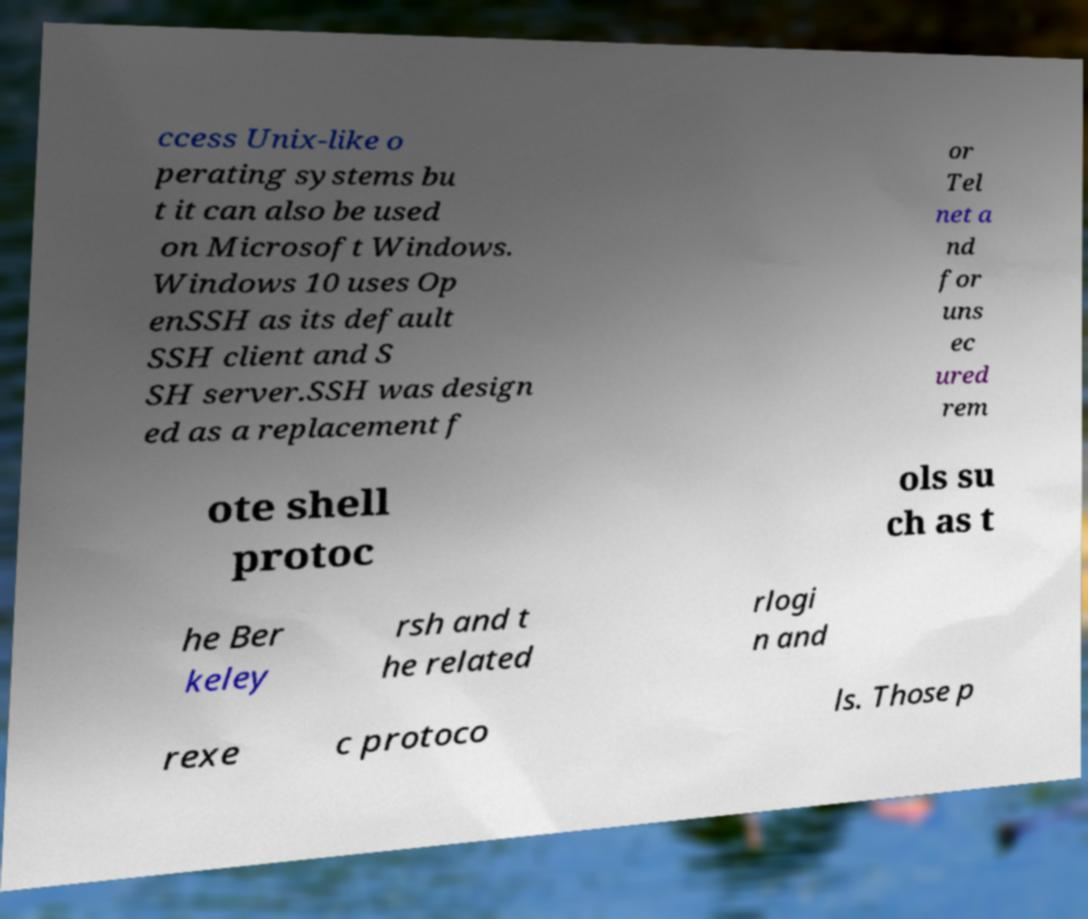Can you accurately transcribe the text from the provided image for me? ccess Unix-like o perating systems bu t it can also be used on Microsoft Windows. Windows 10 uses Op enSSH as its default SSH client and S SH server.SSH was design ed as a replacement f or Tel net a nd for uns ec ured rem ote shell protoc ols su ch as t he Ber keley rsh and t he related rlogi n and rexe c protoco ls. Those p 